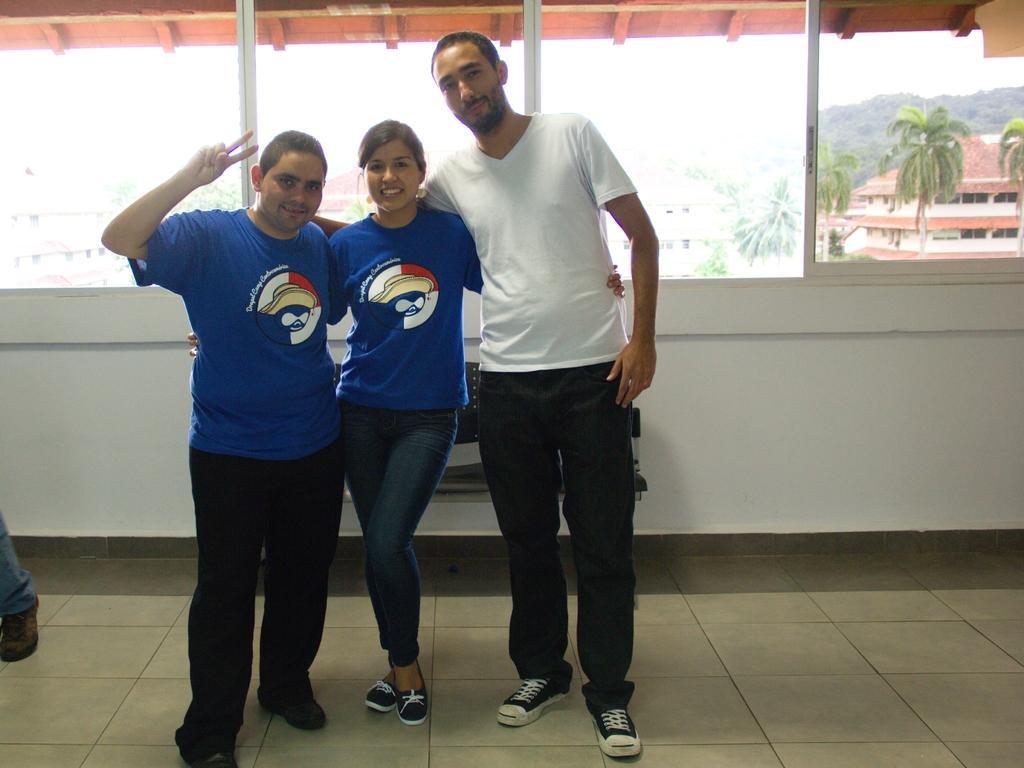Describe this image in one or two sentences. In this image there are three people standing and smiling. At the back there is a window. There are trees, buildings at the back. At the top there is a sky. 